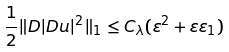Convert formula to latex. <formula><loc_0><loc_0><loc_500><loc_500>\frac { 1 } { 2 } \| D | D u | ^ { 2 } \| _ { 1 } \leq C _ { \lambda } ( \varepsilon ^ { 2 } + \varepsilon \varepsilon _ { 1 } )</formula> 